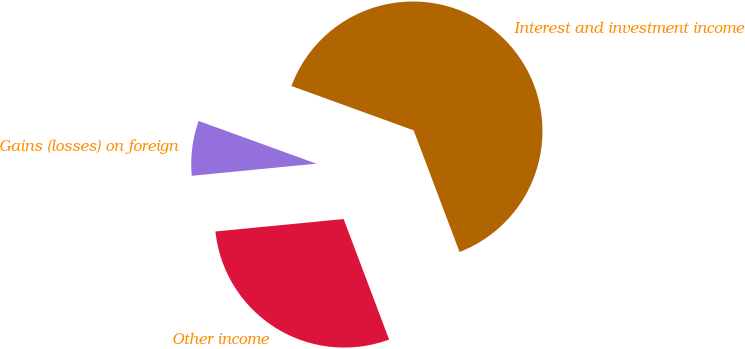<chart> <loc_0><loc_0><loc_500><loc_500><pie_chart><fcel>Interest and investment income<fcel>Gains (losses) on foreign<fcel>Other income<nl><fcel>63.72%<fcel>7.08%<fcel>29.2%<nl></chart> 